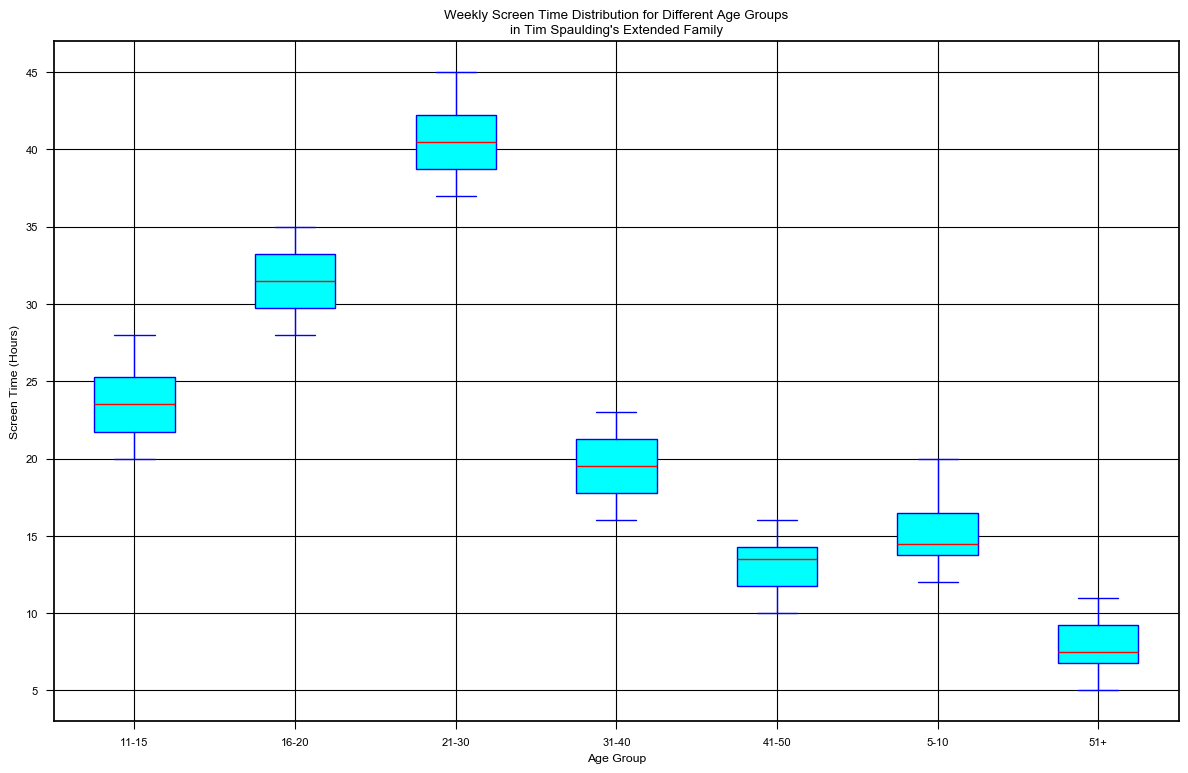What is the median weekly screen time for the 11-15 age group? To find the median, look at the line inside the box for the 11-15 age group. The median is represented by the red line within the blue box.
Answer: 24 Which age group has the highest median weekly screen time? Compare the median lines (red lines) across all age groups. The age group with the highest red line represents the highest median weekly screen time.
Answer: 21-30 What is the interquartile range (IQR) for the 31-40 age group? The IQR is the difference between the 75th percentile (top edge of the box) and the 25th percentile (bottom edge of the box) for the 31-40 age group.
Answer: 6 Compare the variability in weekly screen time between the 16-20 and 41-50 age groups. Which group shows more variability? Variability is represented by the length of the boxes and whiskers. The longer the box and whiskers, the more variability there is. Compare these elements for both age groups.
Answer: 16-20 Which age group has the smallest range of weekly screen time? Range is the difference between the maximum and minimum values (top and bottom of the whiskers). Find the age group with the smallest distance between these points.
Answer: 51+ Is there any age group where the median weekly screen time is exactly at a whole number? Examine the red median lines across all age groups to see if any fall exactly on a whole number (e.g., 14, 21, etc.).
Answer: None For the 5-10 age group, what is the approximate range of weekly screen time? Look at the top and bottom whiskers for the 5-10 age group. The range is the difference between the maximum (top whisker) and minimum (bottom whisker) screen time.
Answer: 8 Comparing the 5-10 and 21-30 age groups, which has a greater interquartile range (IQR)? IQR is the length of the box. Compare the length of the boxes for the two age groups to see which one is greater.
Answer: 21-30 Which age group has a median weekly screen time of less than 15 hours? The median is represented by the red line in the box. Identify the age group(s) with a median line below 15.
Answer: 41-50, 51+ Based on the plot, which age group tends to have a weekly screen time less than 20 hours most frequently? Look for age groups where the majority of the box and whiskers fall below 20 hours.
Answer: 5-10, 31-40, 41-50, 51+ 